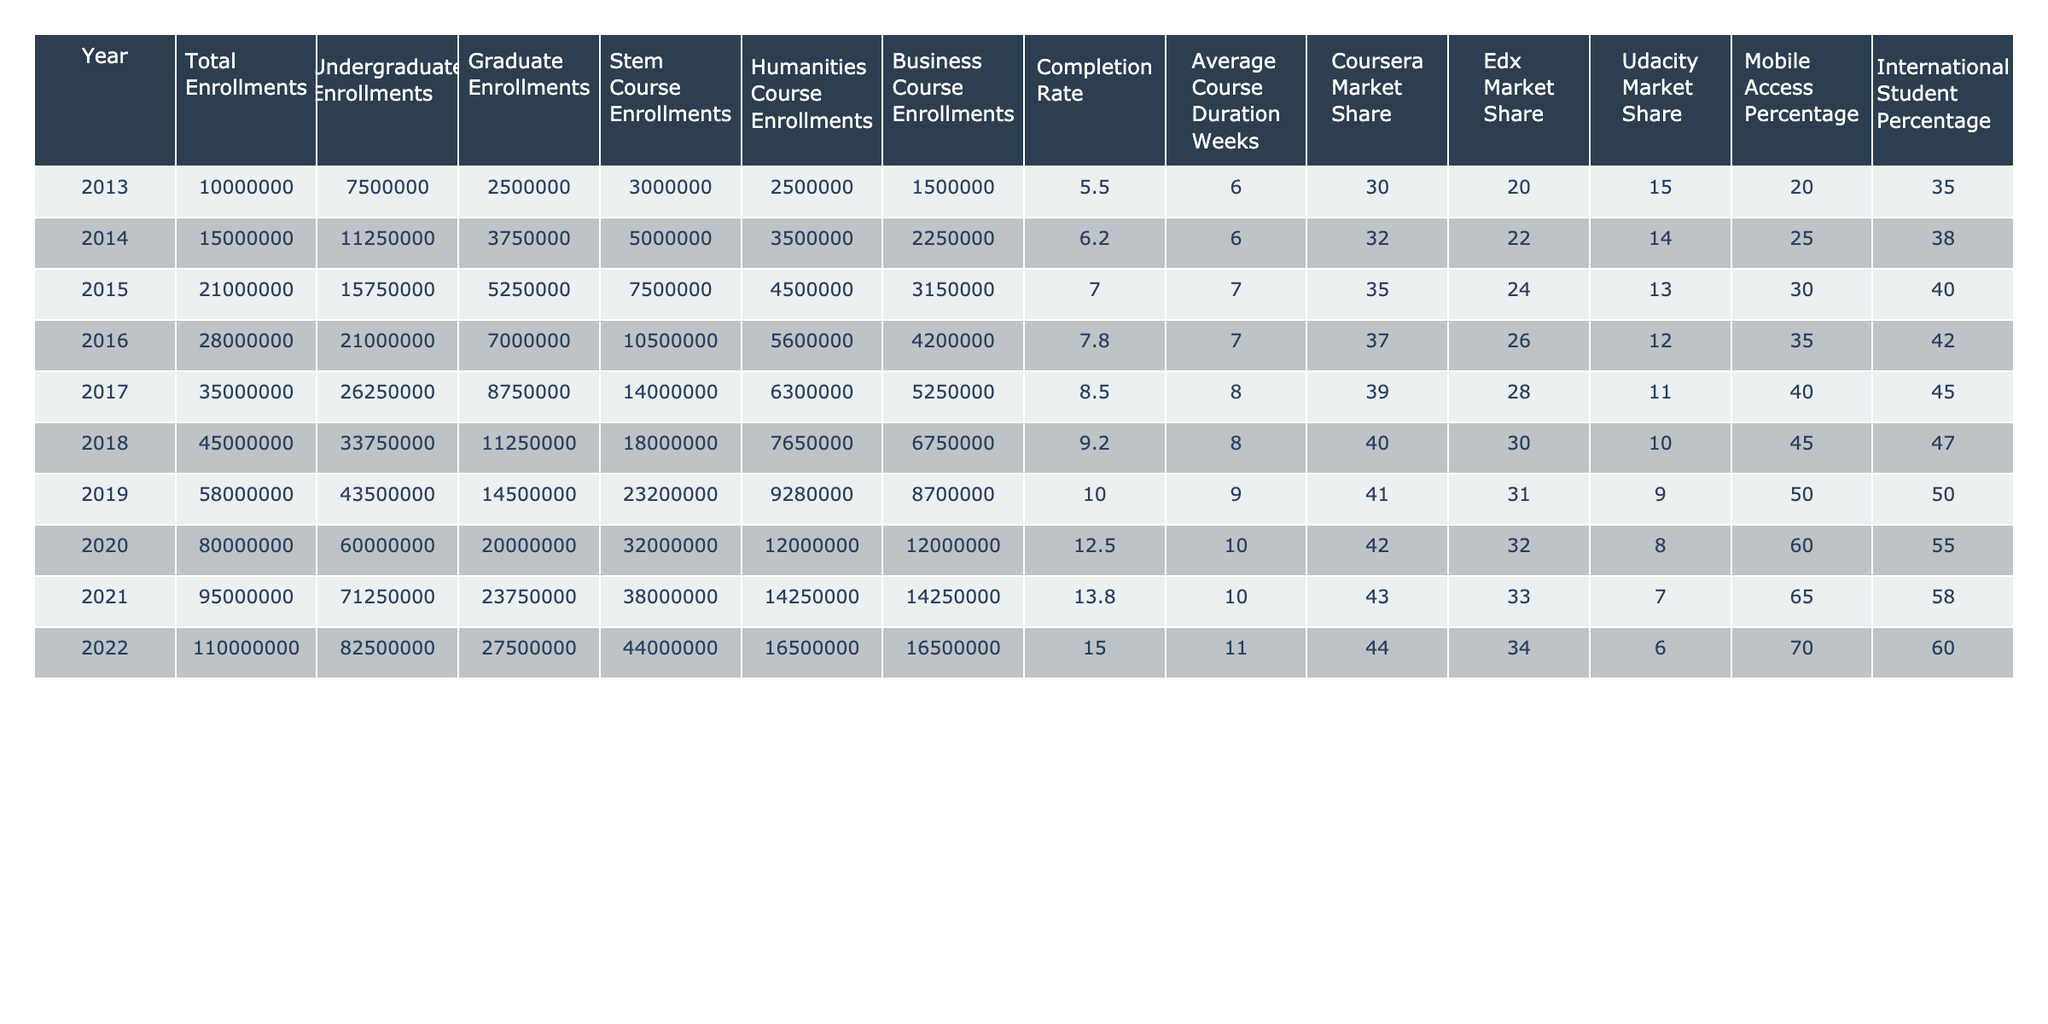What was the completion rate in 2015? Looking at the row for the year 2015 in the table, the completion rate is listed directly as 7.0.
Answer: 7.0 What is the percentage of international students in 2020? In the table, the percentage of international students for the year 2020 is listed in the corresponding row as 55.
Answer: 55 What is the trend in total enrollments from 2013 to 2022? By analyzing the total enrollments from each year, we see a consistent increase from 10,000,000 in 2013 to 110,000,000 in 2022. This indicates a clear upward trend.
Answer: Increasing What was the average course duration in weeks for the years 2016 and 2017? The course duration for 2016 is 7 weeks and for 2017 is 8 weeks. To find the average, we add these values (7 + 8 = 15) and divide by 2, resulting in an average of 7.5 weeks.
Answer: 7.5 In which year was the highest market share for Coursera? The highest Coursera market share is observed in 2022, with a percentage of 44 listed in the corresponding row.
Answer: 44 Did the completion rate increase every year from 2013 to 2022? Upon reviewing the completion rates from the table, we notice that it increased each year starting from 5.5 in 2013 to 15.0 in 2022, indicating a consistent annual increase.
Answer: Yes What is the difference in STEM course enrollments between 2018 and 2020? The STEM course enrollments for 2018 are 18,000,000 and for 2020 are 32,000,000. The difference is calculated by subtracting 18,000,000 from 32,000,000, which equals 14,000,000.
Answer: 14,000,000 How did the percentage of mobile access change from 2013 to 2022? Mobile access in 2013 was 35%, and by 2022 it rose to 70%. To find the change, we subtract 35% from 70%, resulting in an increase of 35 percentage points.
Answer: 35 percentage points What was the year with the lowest graduate enrollments, and how many were there? The lowest graduate enrollments were in 2013, which had 2,500,000 enrollments. This can be confirmed by examining the corresponding row for that year.
Answer: 2,500,000 Is the completion rate for 2020 higher than that of 2019? The completion rate for 2020 is 12.5, while for 2019 it is 10. This comparison shows that 12.5 is greater than 10, confirming that the rate increased.
Answer: Yes 